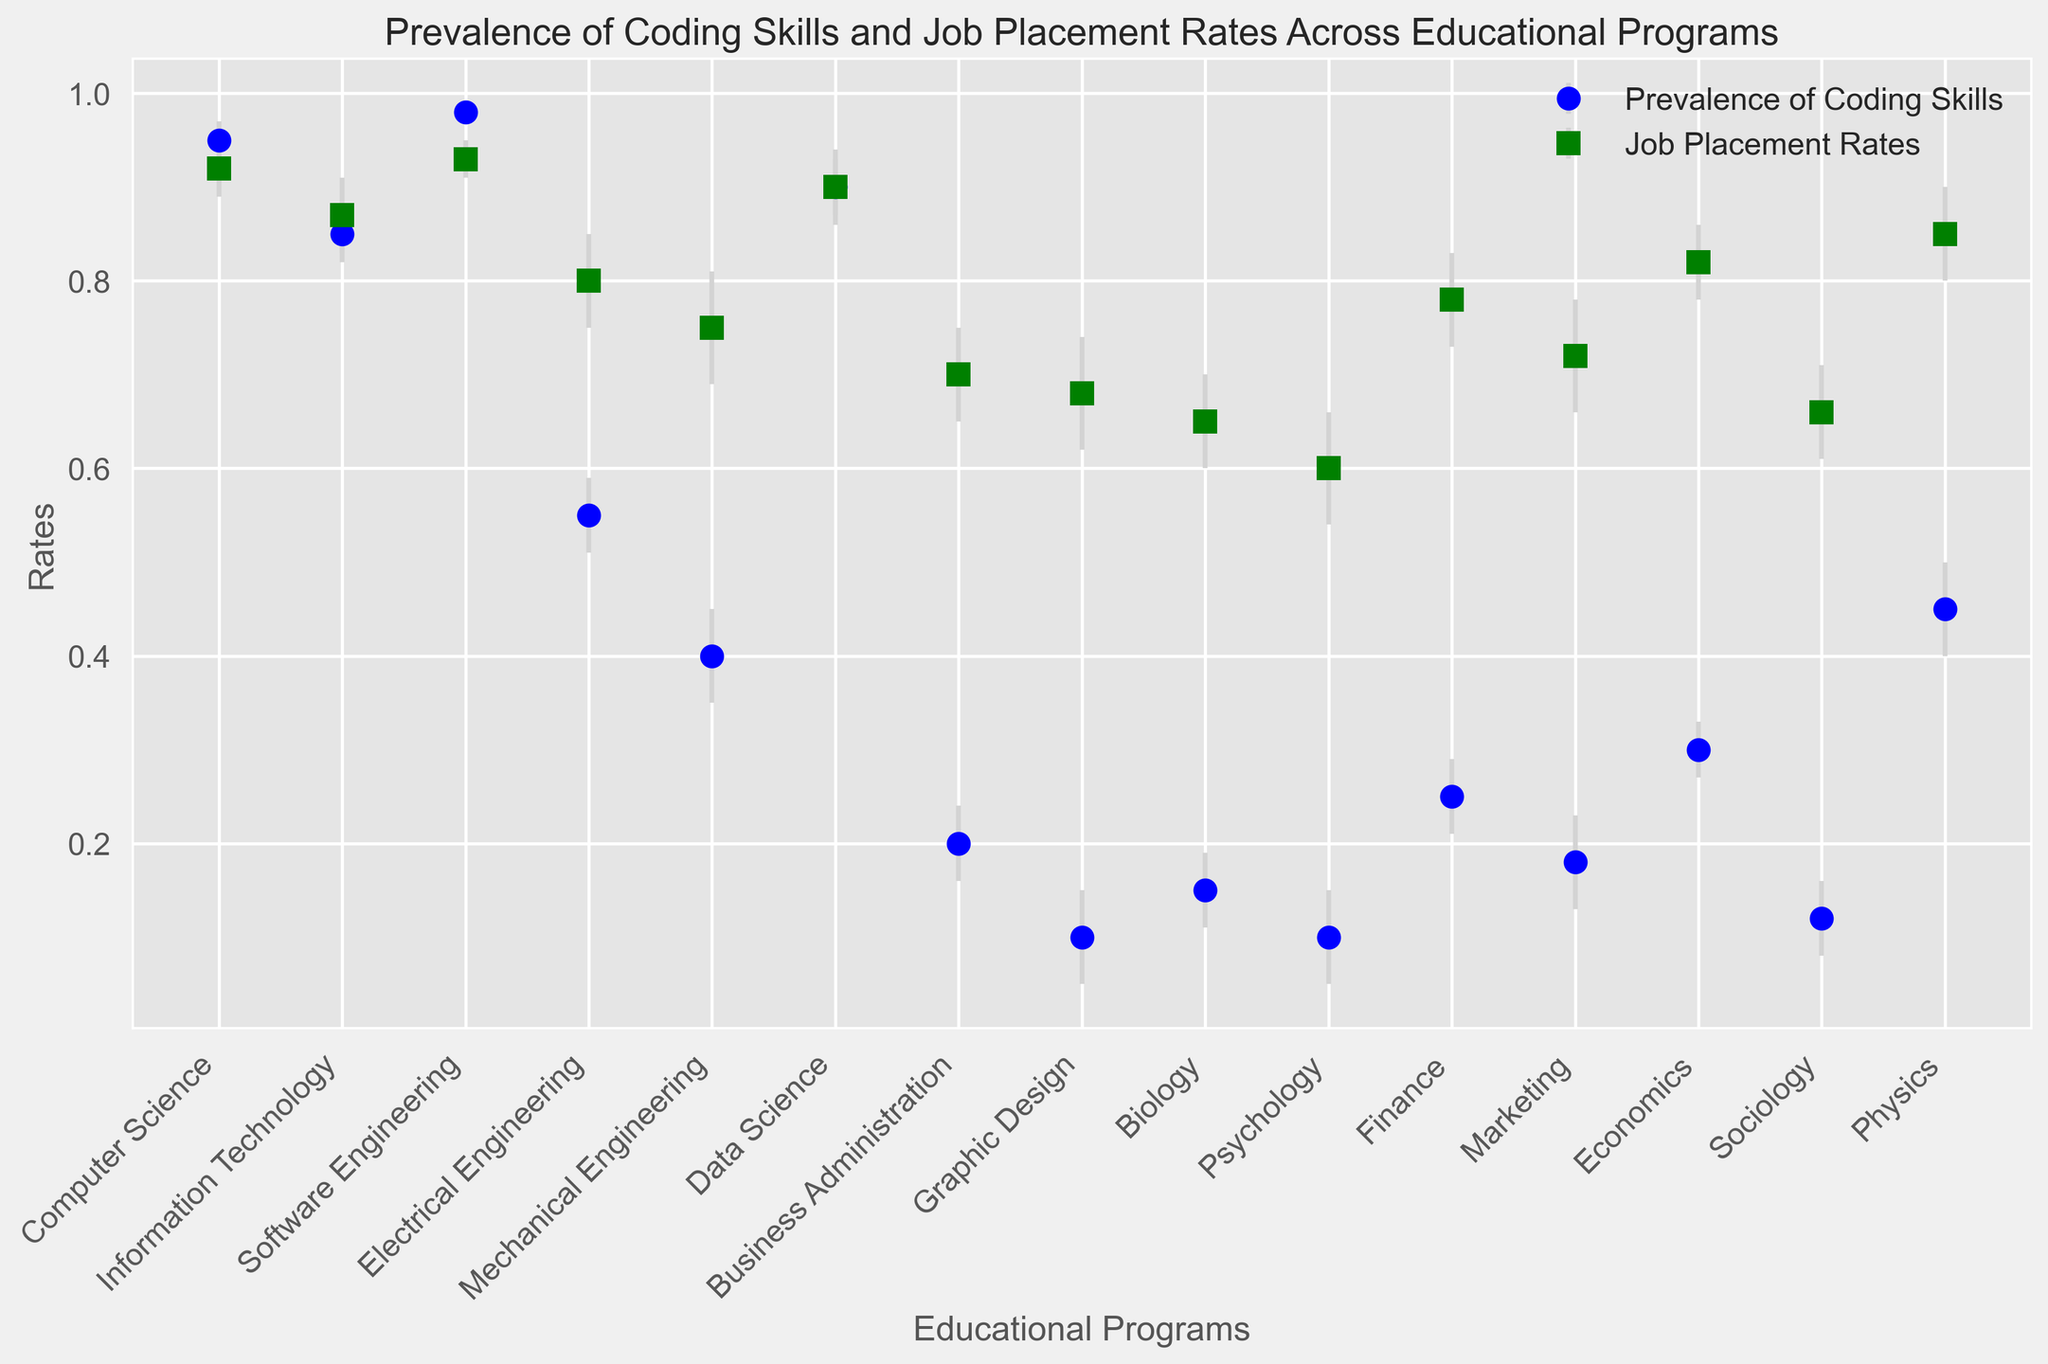Which educational program has the highest prevalence of coding skills? The figure shows that Software Engineering has the highest prevalence of coding skills, as the point representing it is the highest on the y-axis compared to other programs.
Answer: Software Engineering Which program has the smallest difference between prevalence of coding skills and job placement rates? To find the smallest difference, we examine the y-values of both series for each program. Data Science shows the smallest difference, as the points for both prevalence of coding skills and job placement rates are closest together.
Answer: Data Science What is the relative job placement rate of Physics compared to Business Administration? Physics has a job placement rate around 0.85, while Business Administration has a placement rate around 0.70. Comparing these, Physics has a higher job placement rate.
Answer: Higher In which program is the prevalence of coding skills twice the job placement rate? For each program, we check if prevalence ≈ 2 * job placement rate. Business Administration fits this condition with coding skill prevalence around 0.20 and job placement rate around 0.70 (0.20 ≈ 0.2 * 0.70).
Answer: Business Administration What is the overall trend observed between the prevalence of coding skills and job placement rates across programs? Generally, programs with high prevalence of coding skills also have high job placement rates, and vice versa. This trend indicates a positive correlation.
Answer: Positive correlation How does the prevalence of coding skills in Electrical Engineering compare to Mechanical Engineering? Electrical Engineering has a prevalence around 0.55, while Mechanical Engineering has a prevalence around 0.40, showing Electrical Engineering has a higher prevalence of coding skills.
Answer: Higher Among Computer Science, Information Technology, and Software Engineering, which has the highest job placement rate? Comparing the points for job placement, Software Engineering has the highest job placement rate of the three programs mentioned, around 0.93.
Answer: Software Engineering What is the average job placement rate for Biology and Psychology programs? The job placement rate for Biology is 0.65, and for Psychology, it is 0.60. The average is calculated as (0.65 + 0.60) / 2 = 0.625.
Answer: 0.625 If the job placement rate error bars indicate the range, what is the maximum potential job placement rate for Finance? The job placement rate for Finance is around 0.78, and the error margin is 0.05. Therefore, the maximum potential job placement rate is 0.78 + 0.05 = 0.83.
Answer: 0.83 